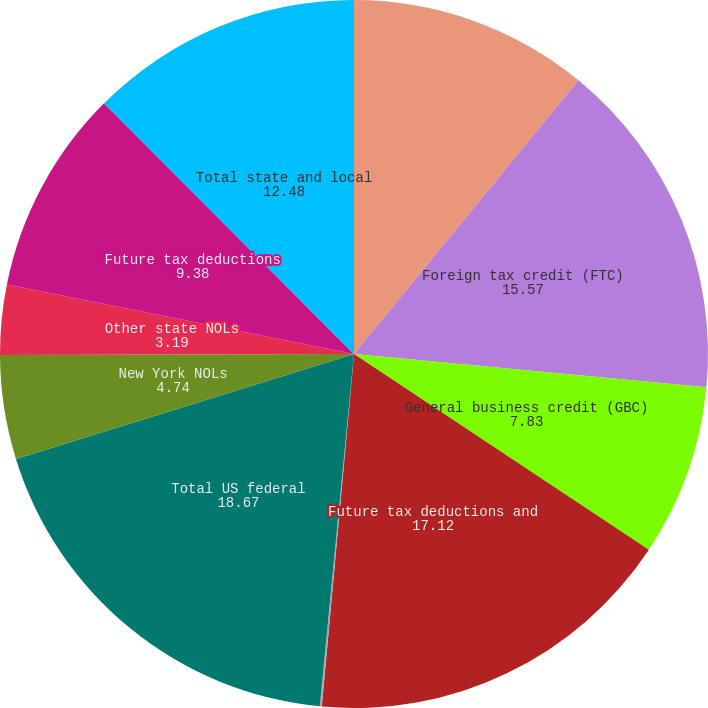Convert chart to OTSL. <chart><loc_0><loc_0><loc_500><loc_500><pie_chart><fcel>Net operating loss (NOL)<fcel>Foreign tax credit (FTC)<fcel>General business credit (GBC)<fcel>Future tax deductions and<fcel>Other<fcel>Total US federal<fcel>New York NOLs<fcel>Other state NOLs<fcel>Future tax deductions<fcel>Total state and local<nl><fcel>10.93%<fcel>15.57%<fcel>7.83%<fcel>17.12%<fcel>0.09%<fcel>18.67%<fcel>4.74%<fcel>3.19%<fcel>9.38%<fcel>12.48%<nl></chart> 